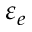Convert formula to latex. <formula><loc_0><loc_0><loc_500><loc_500>\varepsilon _ { e }</formula> 